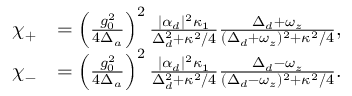<formula> <loc_0><loc_0><loc_500><loc_500>\begin{array} { r l } { \chi _ { + } } & { = \left ( \frac { g _ { 0 } ^ { 2 } } { 4 \Delta _ { a } } \right ) ^ { 2 } \frac { | \alpha _ { d } | ^ { 2 } \kappa _ { 1 } } { \Delta _ { d } ^ { 2 } + \kappa ^ { 2 } / 4 } \frac { \Delta _ { d } + \omega _ { z } } { ( \Delta _ { d } + \omega _ { z } ) ^ { 2 } + \kappa ^ { 2 } / 4 } , } \\ { \chi _ { - } } & { = \left ( \frac { g _ { 0 } ^ { 2 } } { 4 \Delta _ { a } } \right ) ^ { 2 } \frac { | \alpha _ { d } | ^ { 2 } \kappa _ { 1 } } { \Delta _ { d } ^ { 2 } + \kappa ^ { 2 } / 4 } \frac { \Delta _ { d } - \omega _ { z } } { ( \Delta _ { d } - \omega _ { z } ) ^ { 2 } + \kappa ^ { 2 } / 4 } . } \end{array}</formula> 